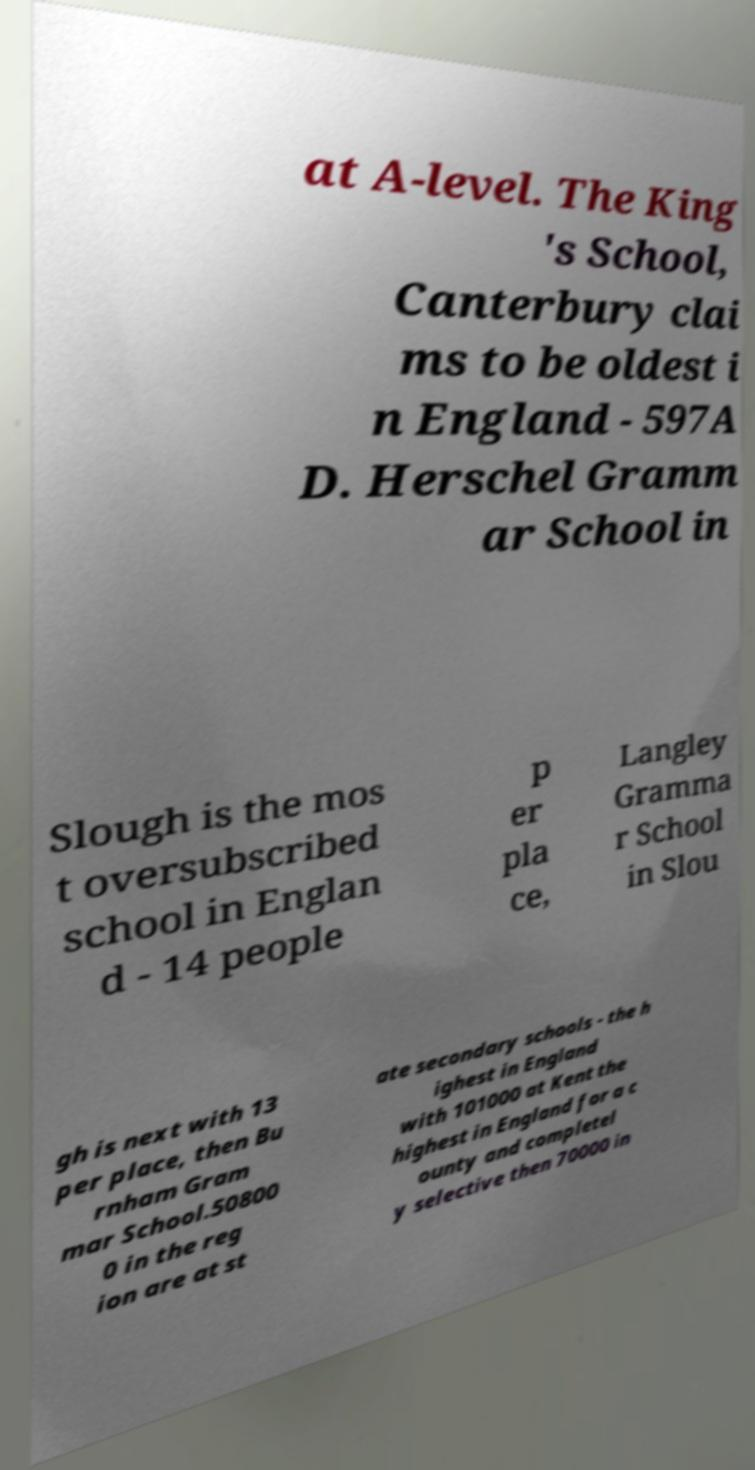Can you read and provide the text displayed in the image?This photo seems to have some interesting text. Can you extract and type it out for me? at A-level. The King 's School, Canterbury clai ms to be oldest i n England - 597A D. Herschel Gramm ar School in Slough is the mos t oversubscribed school in Englan d - 14 people p er pla ce, Langley Gramma r School in Slou gh is next with 13 per place, then Bu rnham Gram mar School.50800 0 in the reg ion are at st ate secondary schools - the h ighest in England with 101000 at Kent the highest in England for a c ounty and completel y selective then 70000 in 